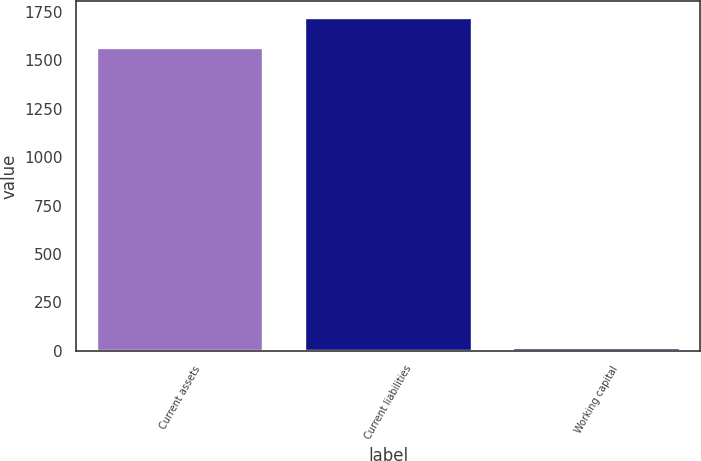Convert chart to OTSL. <chart><loc_0><loc_0><loc_500><loc_500><bar_chart><fcel>Current assets<fcel>Current liabilities<fcel>Working capital<nl><fcel>1563.8<fcel>1720.18<fcel>14.6<nl></chart> 